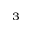<formula> <loc_0><loc_0><loc_500><loc_500>^ { 3 }</formula> 